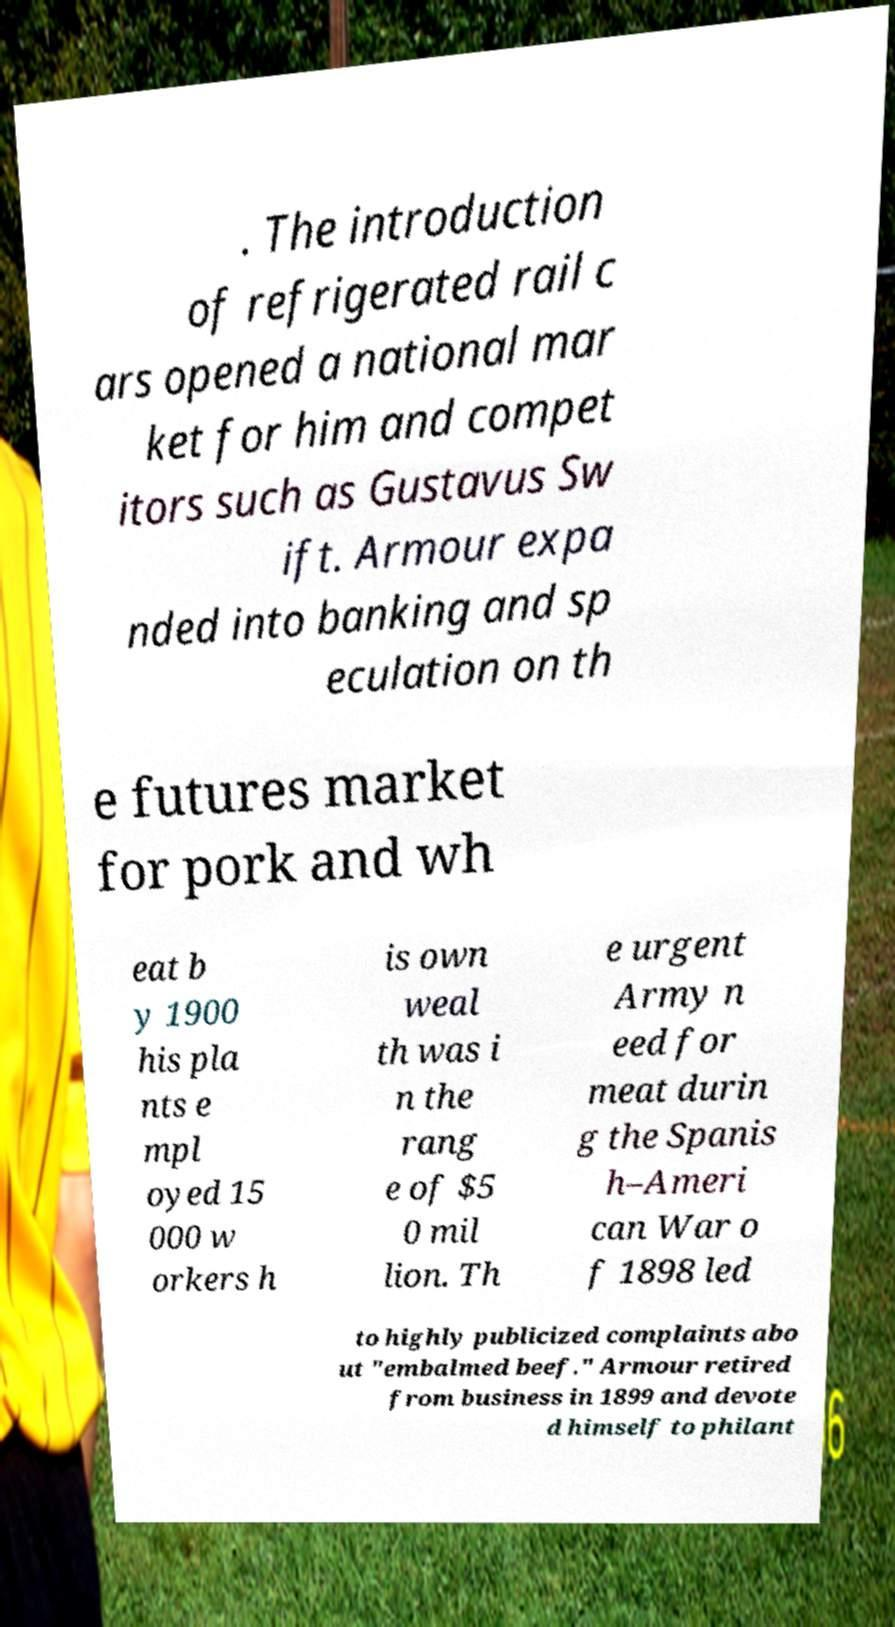I need the written content from this picture converted into text. Can you do that? . The introduction of refrigerated rail c ars opened a national mar ket for him and compet itors such as Gustavus Sw ift. Armour expa nded into banking and sp eculation on th e futures market for pork and wh eat b y 1900 his pla nts e mpl oyed 15 000 w orkers h is own weal th was i n the rang e of $5 0 mil lion. Th e urgent Army n eed for meat durin g the Spanis h–Ameri can War o f 1898 led to highly publicized complaints abo ut "embalmed beef." Armour retired from business in 1899 and devote d himself to philant 